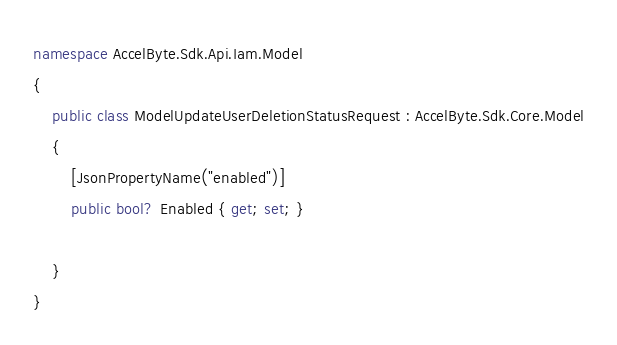Convert code to text. <code><loc_0><loc_0><loc_500><loc_500><_C#_>
namespace AccelByte.Sdk.Api.Iam.Model
{
    public class ModelUpdateUserDeletionStatusRequest : AccelByte.Sdk.Core.Model
    {
        [JsonPropertyName("enabled")]
        public bool? Enabled { get; set; }

    }
}</code> 